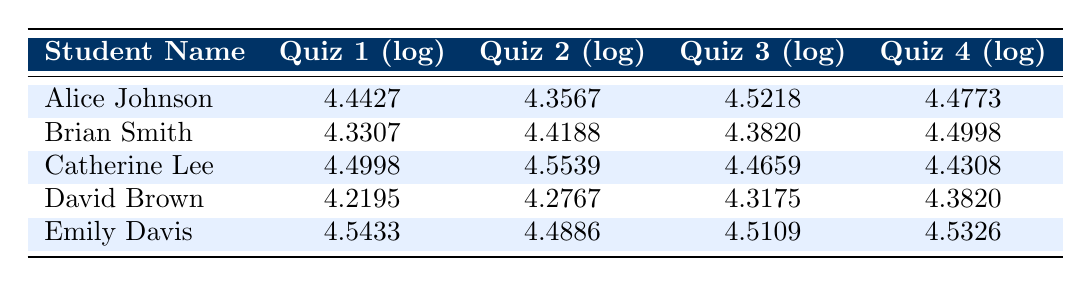What is Alice Johnson's score in Quiz 3? According to the table, Alice Johnson's score in Quiz 3 is directly listed. Looking at the Quiz 3 (log) column for Alice Johnson, we find the value 4.5218.
Answer: 4.5218 Which quiz did Catherine Lee score the highest on? To find which quiz Catherine Lee scored highest on, we can compare the logged scores across all quizzes. The scores are 4.4998 (Quiz 1), 4.5539 (Quiz 2), 4.4659 (Quiz 3), and 4.4308 (Quiz 4). The highest score is 4.5539 in Quiz 2.
Answer: Quiz 2 What is the average score of Brian Smith across all quizzes? To calculate the average, we sum the scores of Brian Smith across all quizzes and then divide by the number of quizzes. His scores are 4.3307 (Quiz 1), 4.4188 (Quiz 2), 4.3820 (Quiz 3), and 4.4998 (Quiz 4). The total sum is 4.3307 + 4.4188 + 4.3820 + 4.4998 = 17.6313. Dividing by 4 gives us an average of 4.4078.
Answer: 4.4078 Did any student score the same in Quiz 4? We can look at the scores in Quiz 4: Alice Johnson (4.4773), Brian Smith (4.4998), Catherine Lee (4.4308), David Brown (4.3820), Emily Davis (4.5326). All scores are different, so there are no students who scored the same in Quiz 4.
Answer: No What is the difference in scores between Emily Davis's Quiz 1 and David Brown's Quiz 1? We take the scores for both students in Quiz 1. Emily Davis scored 4.5433 and David Brown scored 4.2195. The difference can be calculated by subtracting David Brown's score from Emily Davis's score: 4.5433 - 4.2195 = 0.3238.
Answer: 0.3238 Which student has the lowest score in Quiz 2? To find the lowest score in Quiz 2, we compare the values: Alice Johnson (4.3567), Brian Smith (4.4188), Catherine Lee (4.5539), David Brown (4.2767), and Emily Davis (4.4886). The lowest score is 4.2767 from David Brown.
Answer: David Brown What is the median score of all students in Quiz 3? To find the median, we first list the logged scores for Quiz 3: Alice Johnson (4.5218), Brian Smith (4.3820), Catherine Lee (4.4659), David Brown (4.3175), and Emily Davis (4.5109). When arranged in order: 4.3175, 4.3820, 4.4659, 4.5109, 4.5218, the median is the middle value, which is 4.4659.
Answer: 4.4659 Is Emily Davis the highest scorer in all quizzes? To verify this, we need to compare Emily Davis's scores with all other students across all quizzes. Her scores are: Quiz 1 (4.5433), Quiz 2 (4.4886), Quiz 3 (4.5109), Quiz 4 (4.5326). After checking all scores, she is not the highest in any quiz. Catherine Lee has the highest scores in Quiz 2.
Answer: No 